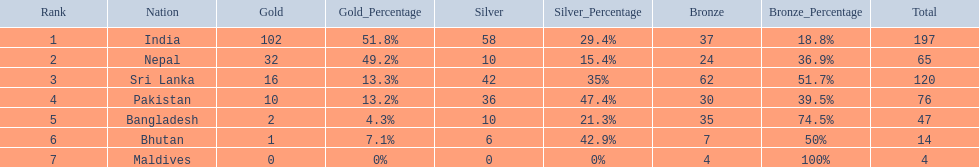How many countries have one more than 10 gold medals? 3. 